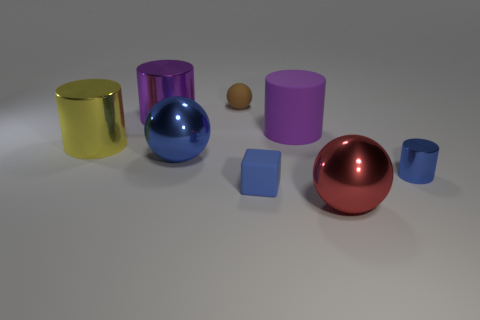Add 1 small blue rubber objects. How many objects exist? 9 Subtract all balls. How many objects are left? 5 Subtract 1 purple cylinders. How many objects are left? 7 Subtract all big purple metallic cubes. Subtract all large purple matte things. How many objects are left? 7 Add 4 purple cylinders. How many purple cylinders are left? 6 Add 2 purple things. How many purple things exist? 4 